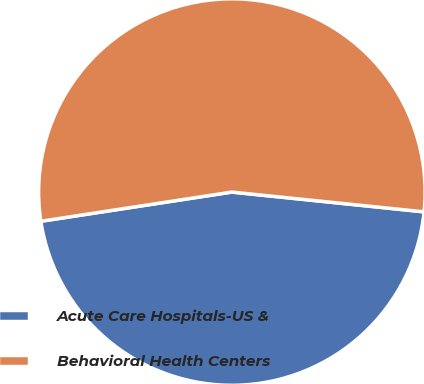<chart> <loc_0><loc_0><loc_500><loc_500><pie_chart><fcel>Acute Care Hospitals-US &<fcel>Behavioral Health Centers<nl><fcel>45.95%<fcel>54.05%<nl></chart> 